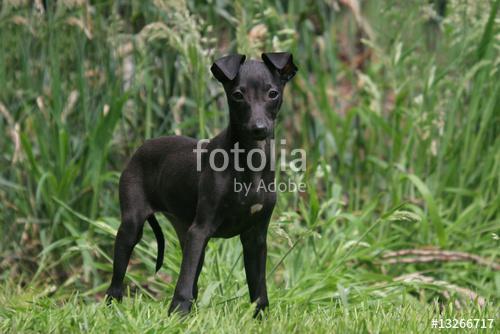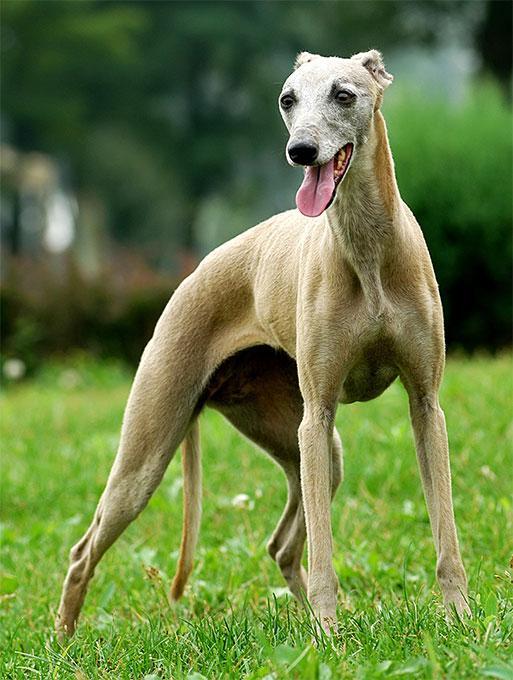The first image is the image on the left, the second image is the image on the right. Given the left and right images, does the statement "At least one image shows a grey dog wearing a color." hold true? Answer yes or no. No. 